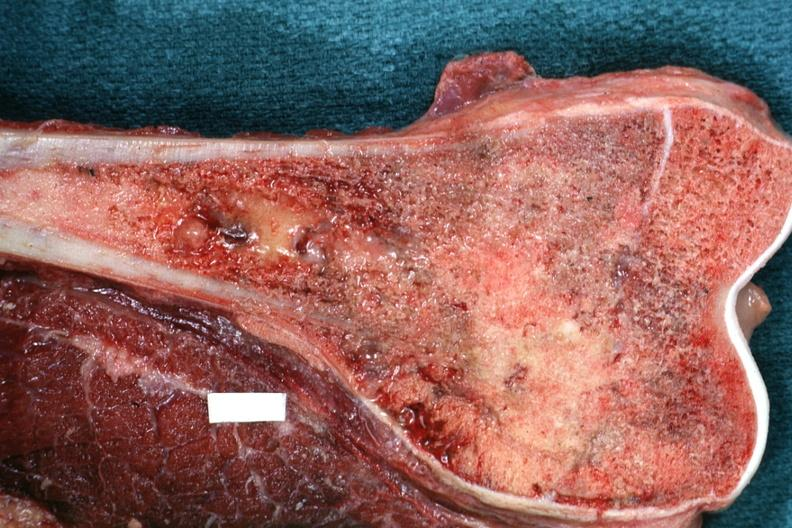how is sectioned femur lesion end excellent example?
Answer the question using a single word or phrase. Distal 